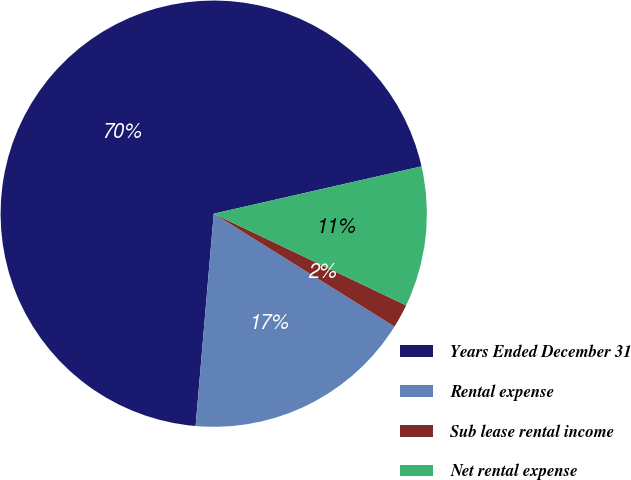Convert chart to OTSL. <chart><loc_0><loc_0><loc_500><loc_500><pie_chart><fcel>Years Ended December 31<fcel>Rental expense<fcel>Sub lease rental income<fcel>Net rental expense<nl><fcel>70.09%<fcel>17.47%<fcel>1.81%<fcel>10.64%<nl></chart> 